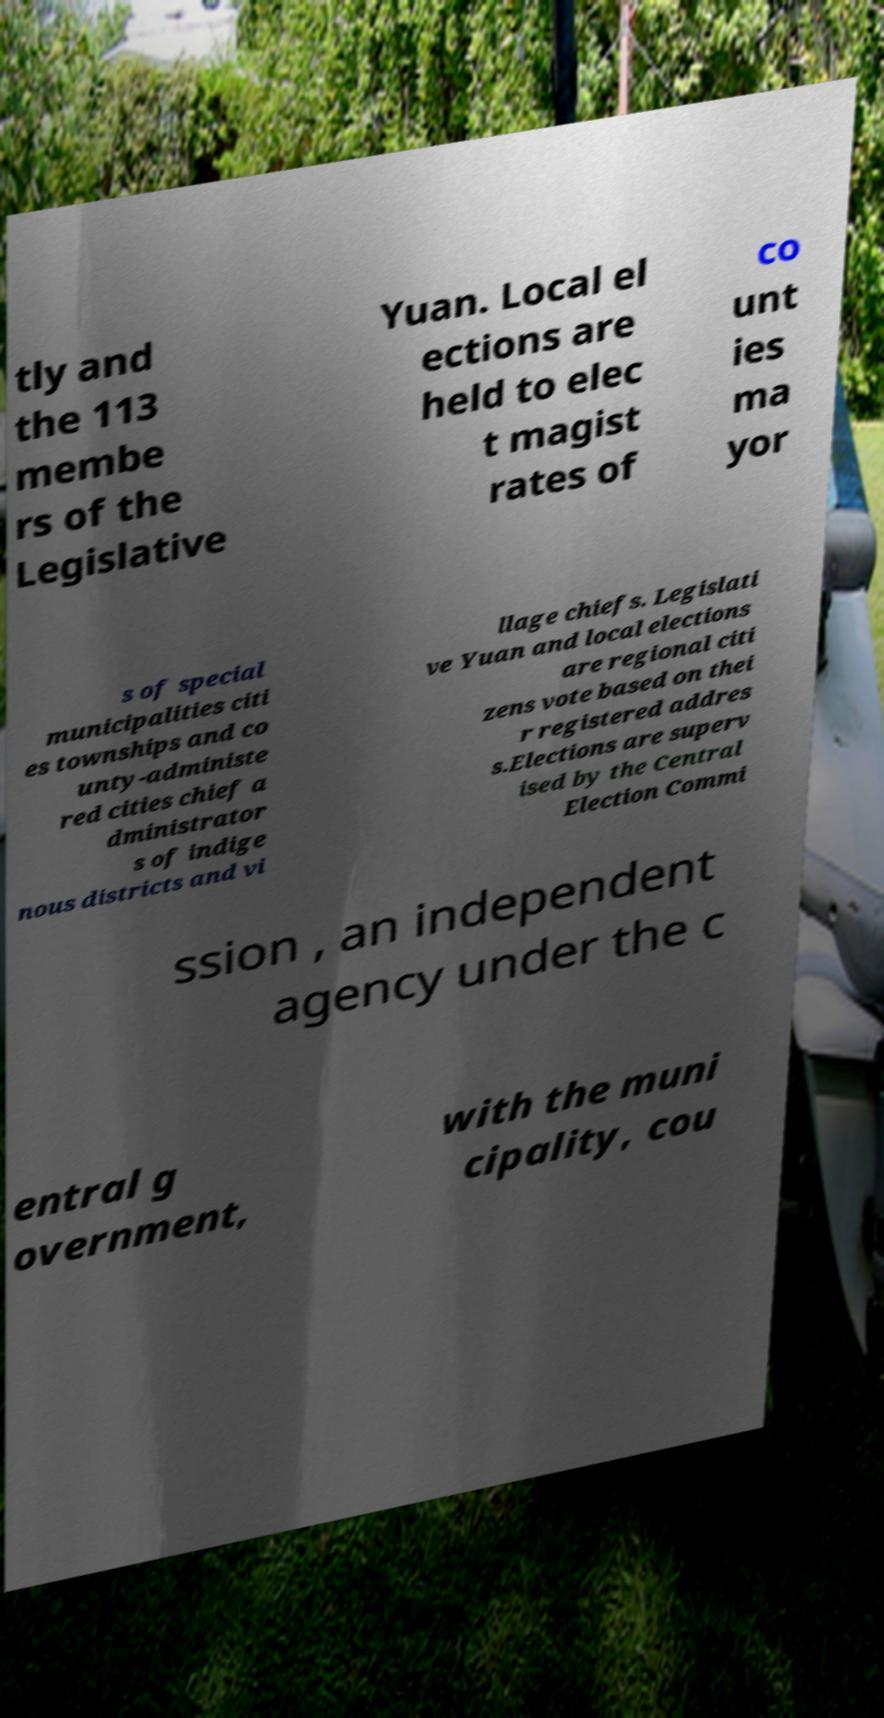For documentation purposes, I need the text within this image transcribed. Could you provide that? tly and the 113 membe rs of the Legislative Yuan. Local el ections are held to elec t magist rates of co unt ies ma yor s of special municipalities citi es townships and co unty-administe red cities chief a dministrator s of indige nous districts and vi llage chiefs. Legislati ve Yuan and local elections are regional citi zens vote based on thei r registered addres s.Elections are superv ised by the Central Election Commi ssion , an independent agency under the c entral g overnment, with the muni cipality, cou 